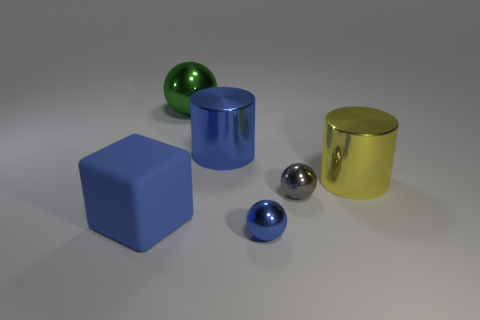Subtract all tiny spheres. How many spheres are left? 1 Subtract all green spheres. How many spheres are left? 2 Subtract all cylinders. How many objects are left? 4 Add 1 gray shiny balls. How many objects exist? 7 Add 1 small shiny things. How many small shiny things are left? 3 Add 4 blue objects. How many blue objects exist? 7 Subtract 1 green balls. How many objects are left? 5 Subtract all brown spheres. Subtract all purple cylinders. How many spheres are left? 3 Subtract all red cylinders. How many yellow balls are left? 0 Subtract all green spheres. Subtract all cylinders. How many objects are left? 3 